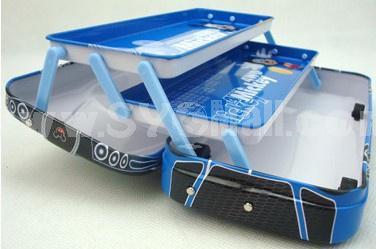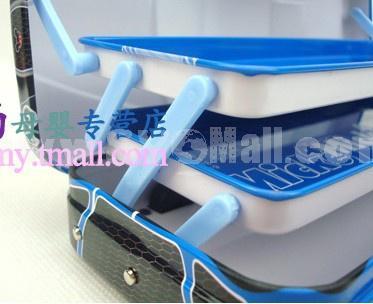The first image is the image on the left, the second image is the image on the right. Evaluate the accuracy of this statement regarding the images: "An image shows three variations of the same kind of case, each a different color.". Is it true? Answer yes or no. No. The first image is the image on the left, the second image is the image on the right. For the images displayed, is the sentence "There is at least one pen inside an open 3 layered pencil case." factually correct? Answer yes or no. No. 